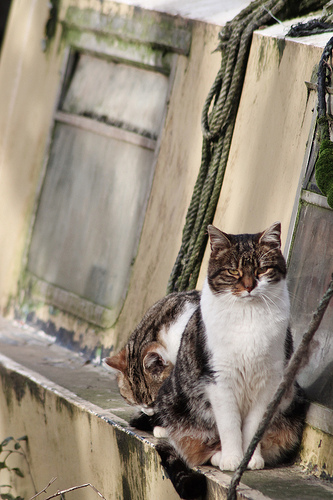<image>
Is there a cat under the rope? No. The cat is not positioned under the rope. The vertical relationship between these objects is different. 